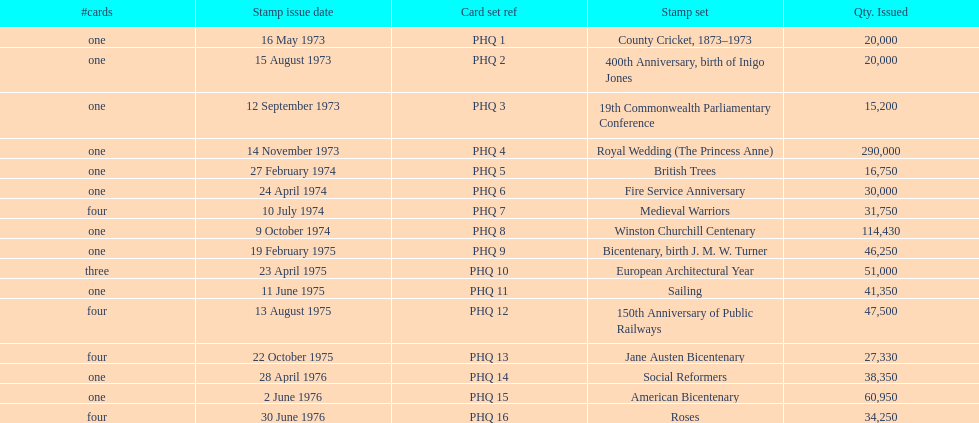Which stamp set had the greatest quantity issued? Royal Wedding (The Princess Anne). 